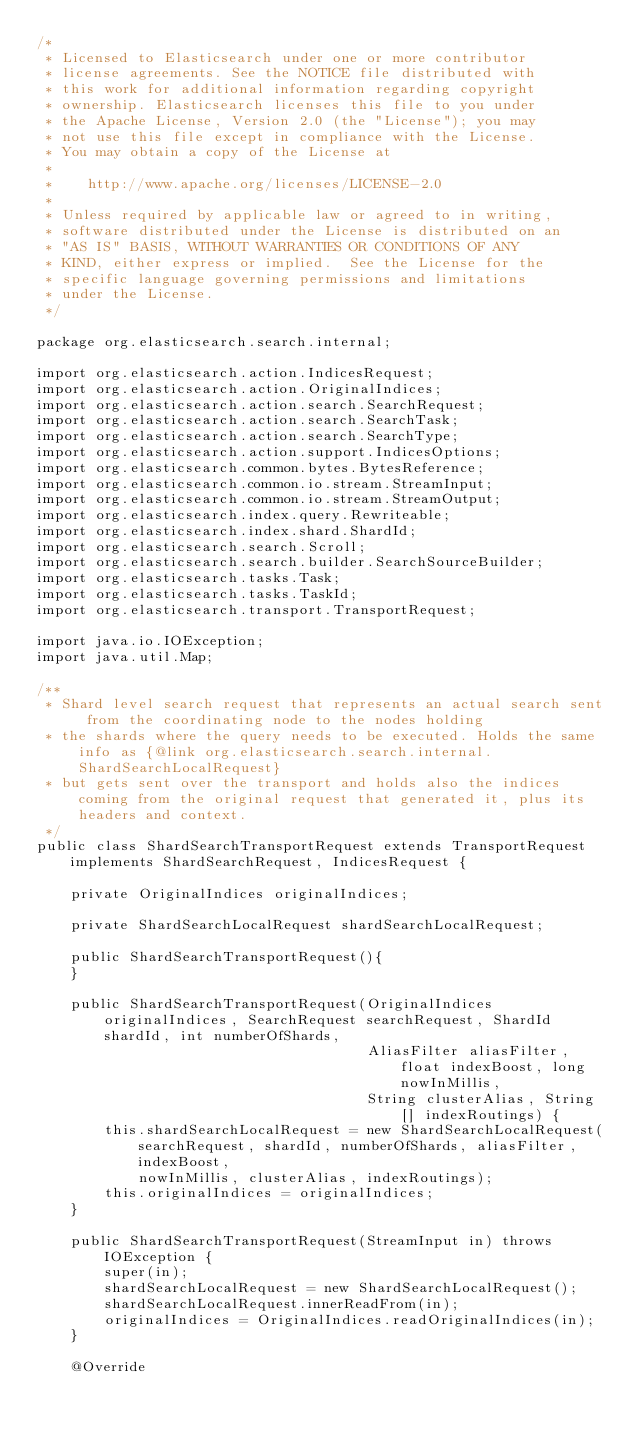<code> <loc_0><loc_0><loc_500><loc_500><_Java_>/*
 * Licensed to Elasticsearch under one or more contributor
 * license agreements. See the NOTICE file distributed with
 * this work for additional information regarding copyright
 * ownership. Elasticsearch licenses this file to you under
 * the Apache License, Version 2.0 (the "License"); you may
 * not use this file except in compliance with the License.
 * You may obtain a copy of the License at
 *
 *    http://www.apache.org/licenses/LICENSE-2.0
 *
 * Unless required by applicable law or agreed to in writing,
 * software distributed under the License is distributed on an
 * "AS IS" BASIS, WITHOUT WARRANTIES OR CONDITIONS OF ANY
 * KIND, either express or implied.  See the License for the
 * specific language governing permissions and limitations
 * under the License.
 */

package org.elasticsearch.search.internal;

import org.elasticsearch.action.IndicesRequest;
import org.elasticsearch.action.OriginalIndices;
import org.elasticsearch.action.search.SearchRequest;
import org.elasticsearch.action.search.SearchTask;
import org.elasticsearch.action.search.SearchType;
import org.elasticsearch.action.support.IndicesOptions;
import org.elasticsearch.common.bytes.BytesReference;
import org.elasticsearch.common.io.stream.StreamInput;
import org.elasticsearch.common.io.stream.StreamOutput;
import org.elasticsearch.index.query.Rewriteable;
import org.elasticsearch.index.shard.ShardId;
import org.elasticsearch.search.Scroll;
import org.elasticsearch.search.builder.SearchSourceBuilder;
import org.elasticsearch.tasks.Task;
import org.elasticsearch.tasks.TaskId;
import org.elasticsearch.transport.TransportRequest;

import java.io.IOException;
import java.util.Map;

/**
 * Shard level search request that represents an actual search sent from the coordinating node to the nodes holding
 * the shards where the query needs to be executed. Holds the same info as {@link org.elasticsearch.search.internal.ShardSearchLocalRequest}
 * but gets sent over the transport and holds also the indices coming from the original request that generated it, plus its headers and context.
 */
public class ShardSearchTransportRequest extends TransportRequest implements ShardSearchRequest, IndicesRequest {

    private OriginalIndices originalIndices;

    private ShardSearchLocalRequest shardSearchLocalRequest;

    public ShardSearchTransportRequest(){
    }

    public ShardSearchTransportRequest(OriginalIndices originalIndices, SearchRequest searchRequest, ShardId shardId, int numberOfShards,
                                       AliasFilter aliasFilter, float indexBoost, long nowInMillis,
                                       String clusterAlias, String[] indexRoutings) {
        this.shardSearchLocalRequest = new ShardSearchLocalRequest(searchRequest, shardId, numberOfShards, aliasFilter, indexBoost,
            nowInMillis, clusterAlias, indexRoutings);
        this.originalIndices = originalIndices;
    }

    public ShardSearchTransportRequest(StreamInput in) throws IOException {
        super(in);
        shardSearchLocalRequest = new ShardSearchLocalRequest();
        shardSearchLocalRequest.innerReadFrom(in);
        originalIndices = OriginalIndices.readOriginalIndices(in);
    }

    @Override</code> 